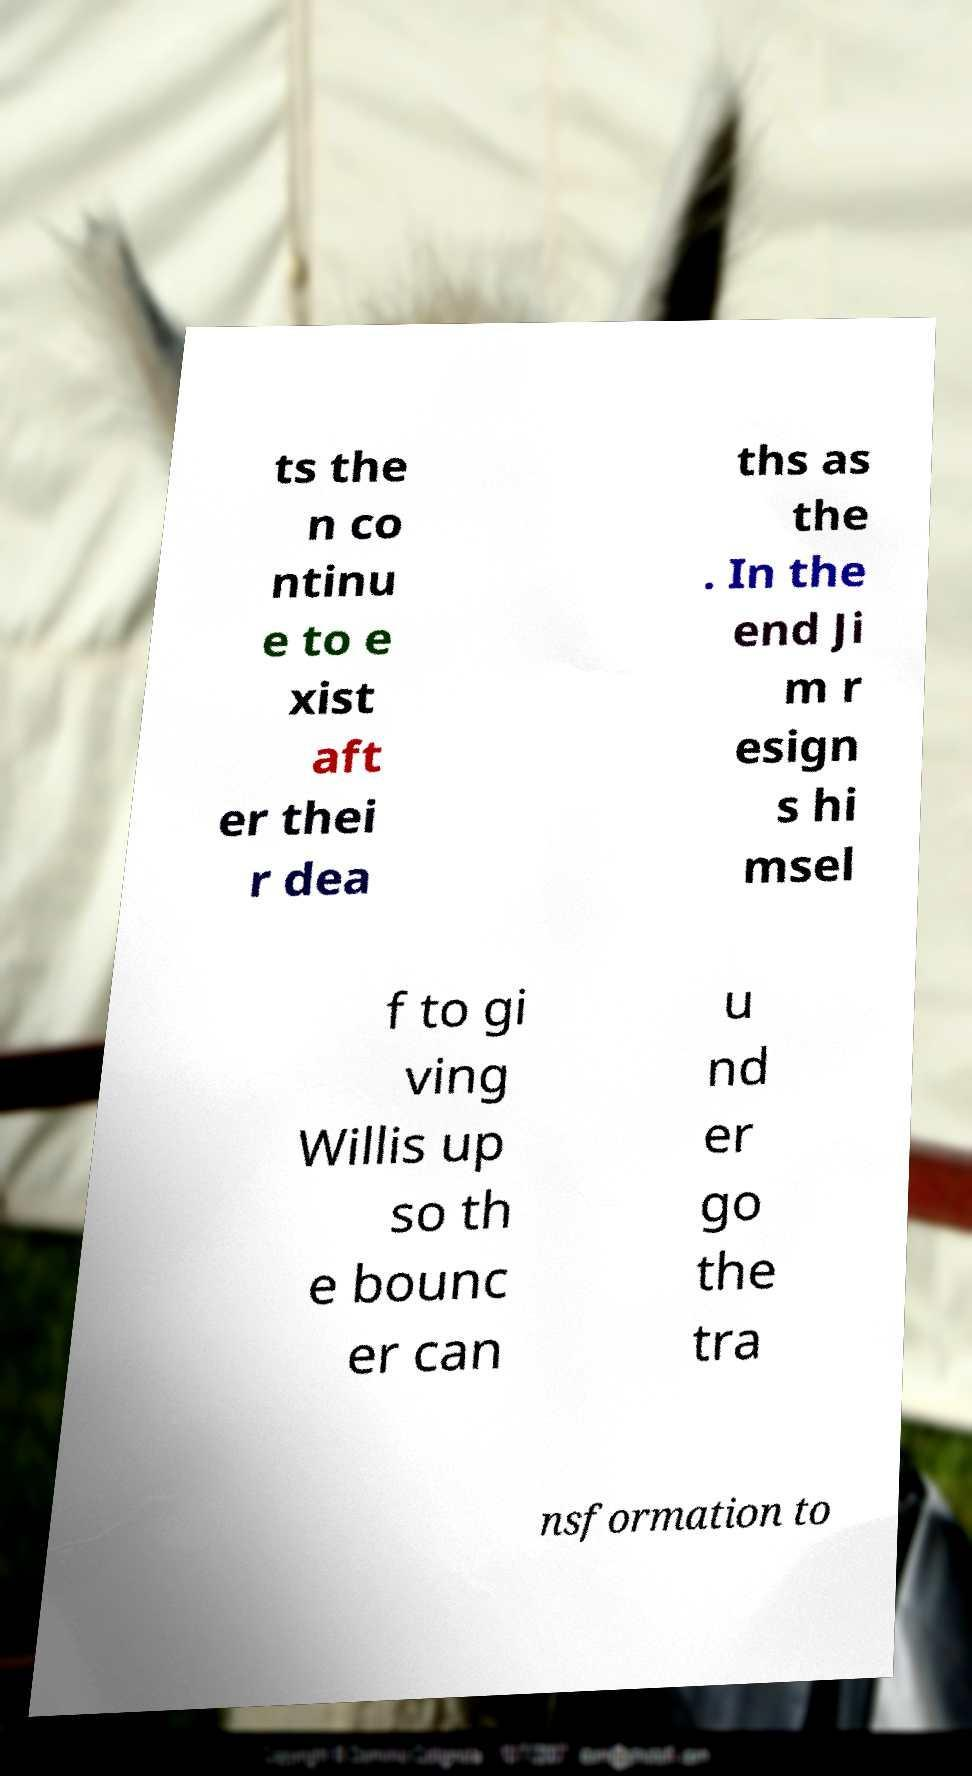Can you accurately transcribe the text from the provided image for me? ts the n co ntinu e to e xist aft er thei r dea ths as the . In the end Ji m r esign s hi msel f to gi ving Willis up so th e bounc er can u nd er go the tra nsformation to 